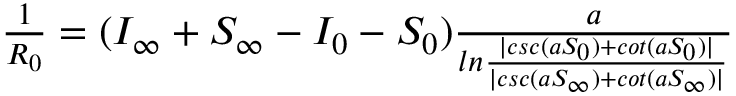<formula> <loc_0><loc_0><loc_500><loc_500>\begin{array} { r } { \frac { 1 } { R _ { 0 } } = ( I _ { \infty } + S _ { \infty } - I _ { 0 } - S _ { 0 } ) \frac { a } { \ln \frac { | c s c ( a S _ { 0 } ) + c o t ( a S _ { 0 } ) | } { | c s c ( a S _ { \infty } ) + c o t ( a S _ { \infty } ) | } } } \end{array}</formula> 